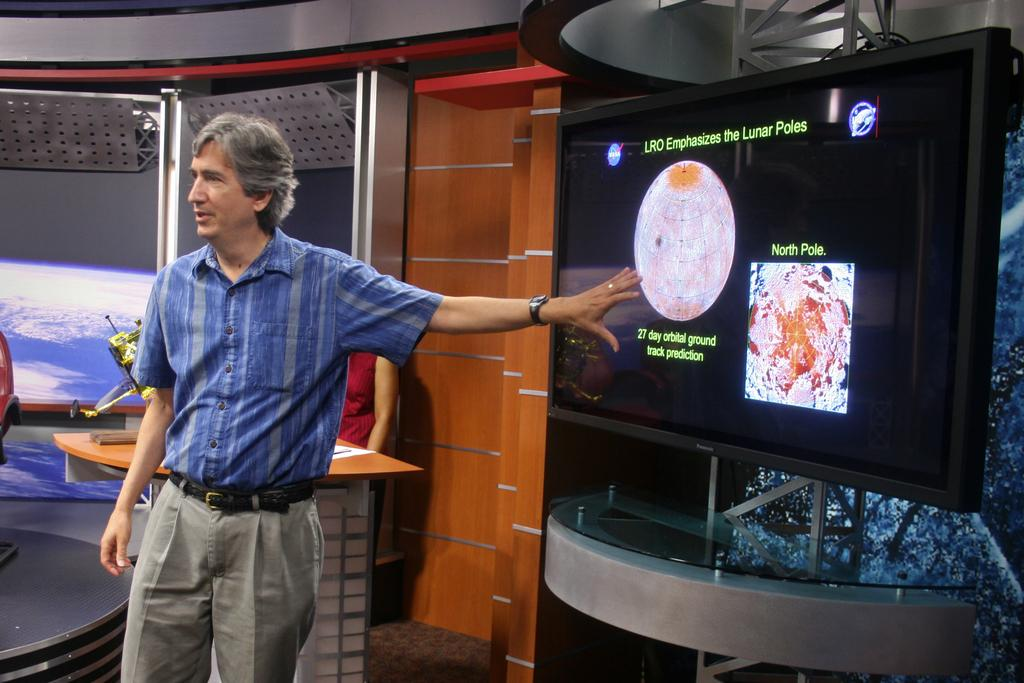What is the man in the image doing? The man is standing near the television. What piece of furniture is present in the image? There is a table in the image. What object is on the table? There is a paper on the table. What flavor of powder can be seen bursting from the television in the image? There is no powder or bursting effect present in the image; it features a man standing near a television with a table and paper on it. 